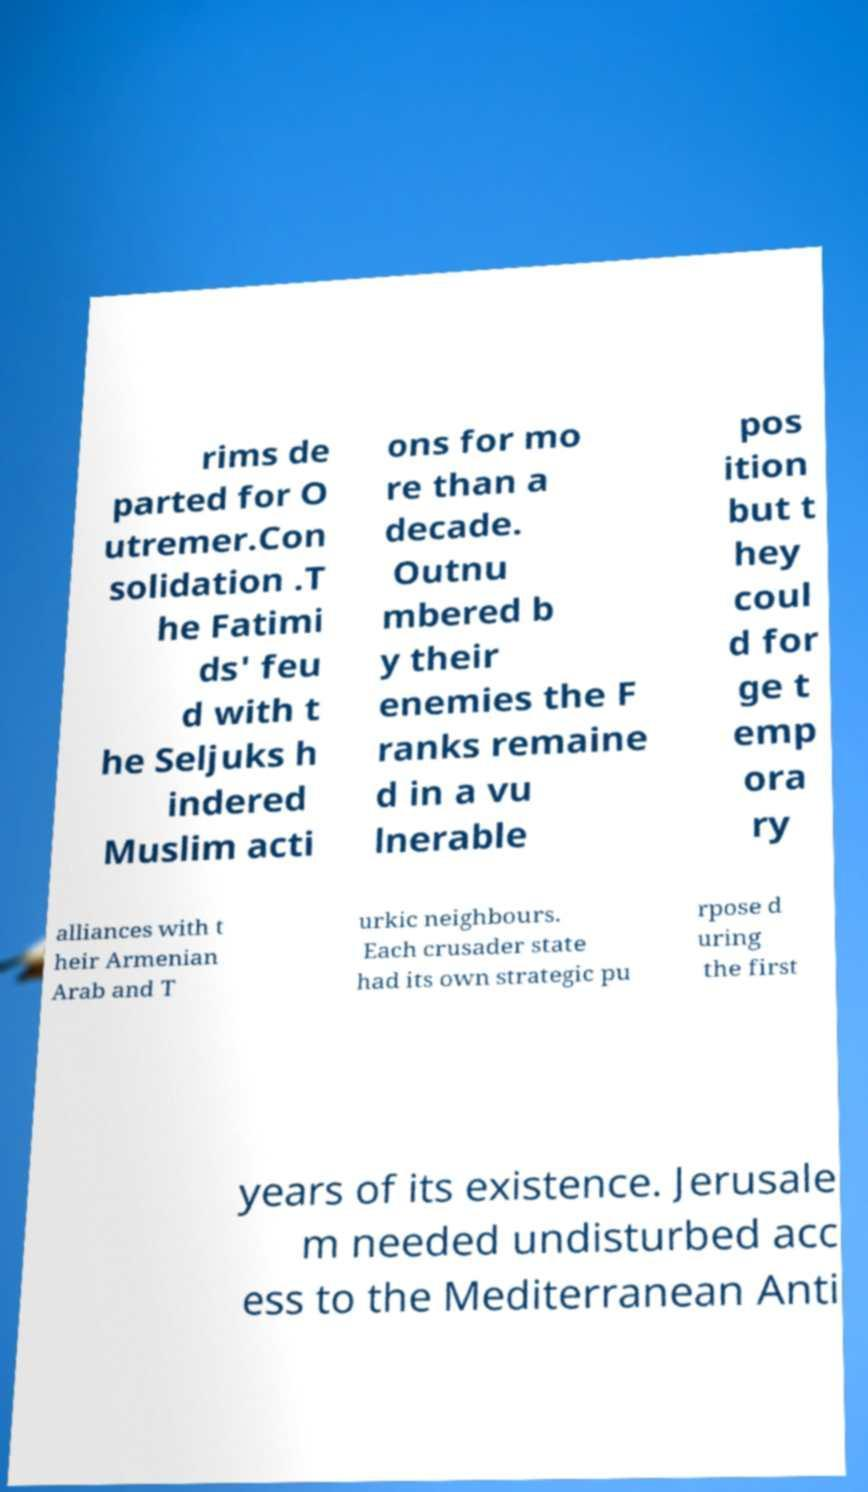Could you extract and type out the text from this image? rims de parted for O utremer.Con solidation .T he Fatimi ds' feu d with t he Seljuks h indered Muslim acti ons for mo re than a decade. Outnu mbered b y their enemies the F ranks remaine d in a vu lnerable pos ition but t hey coul d for ge t emp ora ry alliances with t heir Armenian Arab and T urkic neighbours. Each crusader state had its own strategic pu rpose d uring the first years of its existence. Jerusale m needed undisturbed acc ess to the Mediterranean Anti 